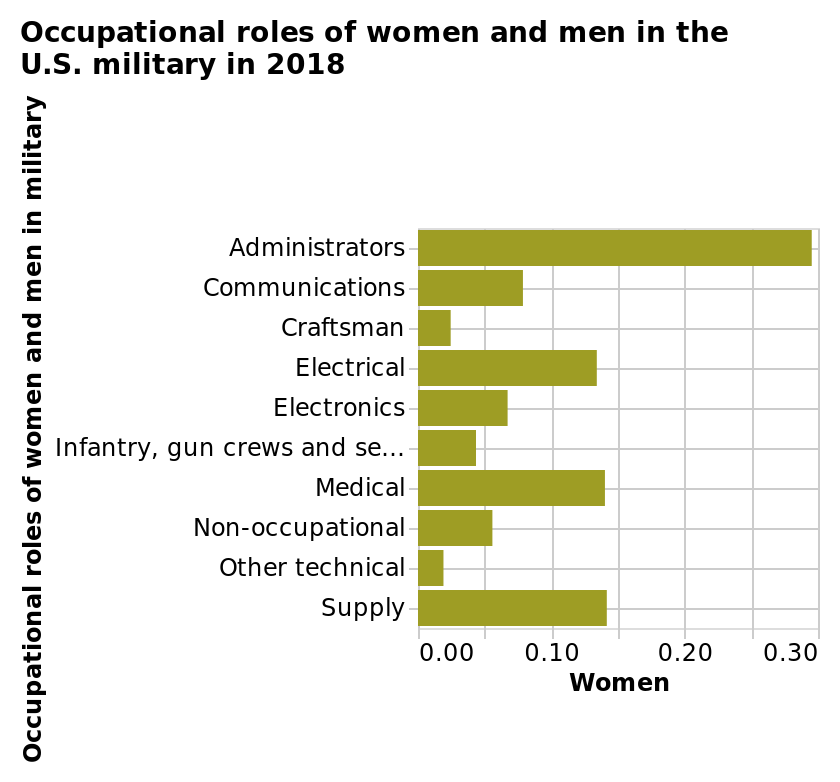<image>
How many women were employed in the US military as administrators in 2018?  The exact number of women employed as administrators in the US military in 2018 is not mentioned in the description. Were there many women employed as craftsmen in the US military? No, very few women were employed as craftsmen in the US military. The exact number is not specified in the description. Were women the majority of military administrators in 2018? No, women were less than 30% of all military administrators in 2018. What was the most common occupation for women in the US military in 2018? The most common occupation for women in the US military in 2018 was administrators. please enumerates aspects of the construction of the chart Occupational roles of women and men in the U.S. military in 2018 is a bar chart. The y-axis plots Occupational roles of women and men in military while the x-axis measures Women. 